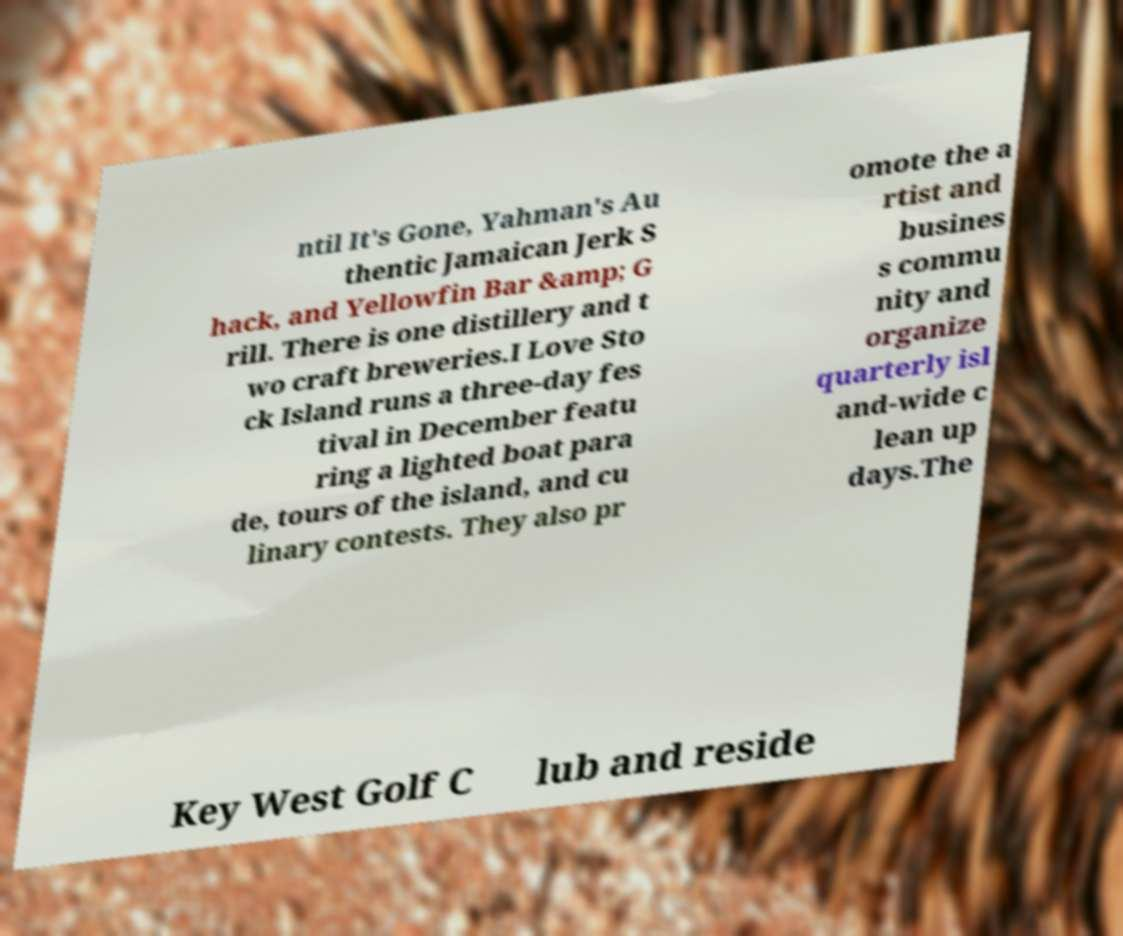Please identify and transcribe the text found in this image. ntil It's Gone, Yahman's Au thentic Jamaican Jerk S hack, and Yellowfin Bar &amp; G rill. There is one distillery and t wo craft breweries.I Love Sto ck Island runs a three-day fes tival in December featu ring a lighted boat para de, tours of the island, and cu linary contests. They also pr omote the a rtist and busines s commu nity and organize quarterly isl and-wide c lean up days.The Key West Golf C lub and reside 